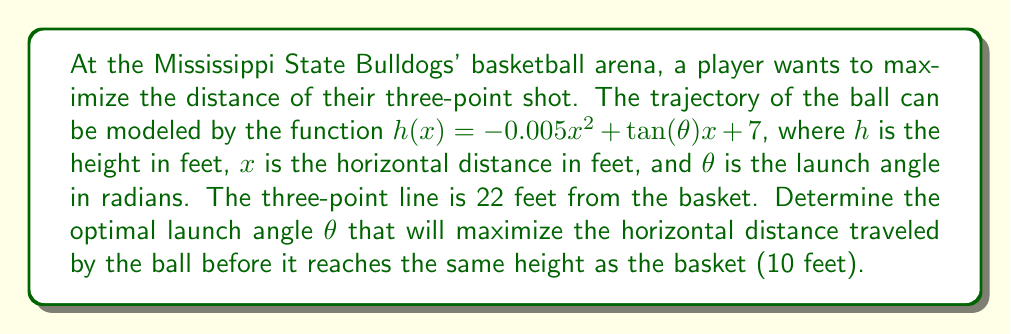Show me your answer to this math problem. To solve this problem, we'll follow these steps:

1) First, we need to find the horizontal distance traveled when the ball reaches 10 feet (basket height). We can do this by setting $h(x) = 10$ and solving for $x$:

   $10 = -0.005x^2 + \tan(\theta)x + 7$
   $3 = -0.005x^2 + \tan(\theta)x$

2) This is a quadratic equation. The maximum distance will occur when this equation has exactly one solution (tangent point). This happens when the discriminant is zero. The discriminant for a quadratic $ax^2 + bx + c = 0$ is $b^2 - 4ac$.

3) In our case, $a = -0.005$, $b = \tan(\theta)$, and $c = -3$. Setting the discriminant to zero:

   $\tan^2(\theta) - 4(-0.005)(-3) = 0$
   $\tan^2(\theta) = 0.06$
   $\tan(\theta) = \sqrt{0.06} \approx 0.2449$

4) To find $\theta$, we take the inverse tangent:

   $\theta = \arctan(\sqrt{0.06}) \approx 0.2419$ radians

5) Convert to degrees:

   $\theta \approx 0.2419 \times \frac{180}{\pi} \approx 13.86°$
Answer: $13.86°$ 